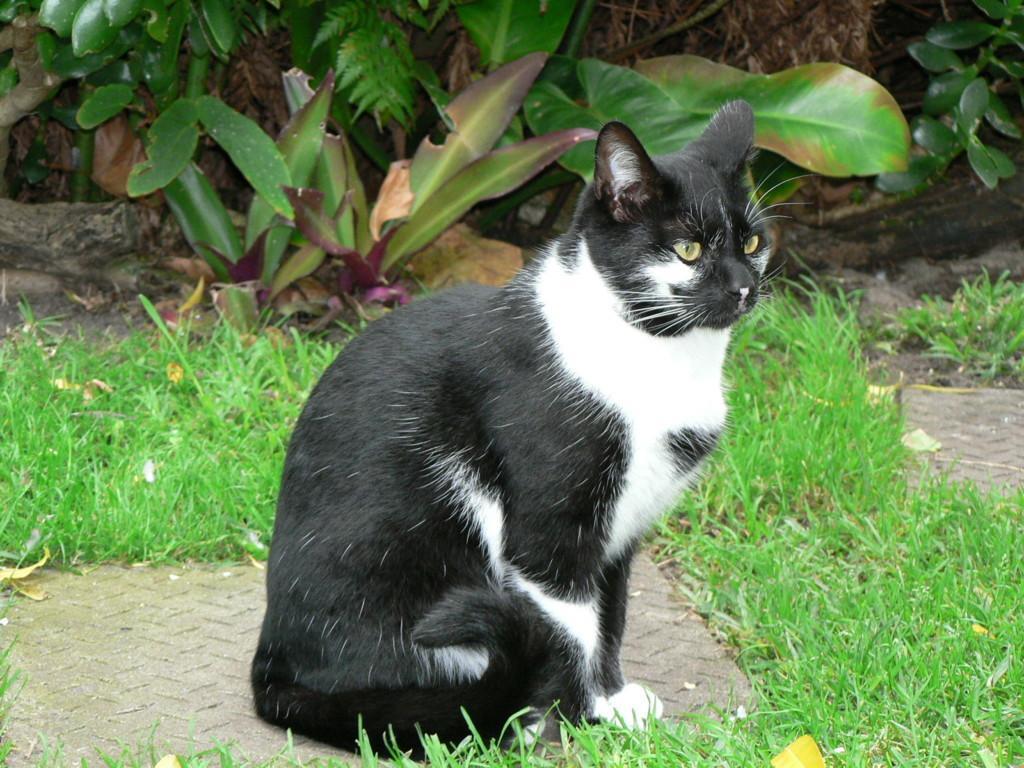In one or two sentences, can you explain what this image depicts? In this image in the front there's grass on the ground. In the center there is a cat. In the background there are plants. 